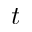<formula> <loc_0><loc_0><loc_500><loc_500>t</formula> 